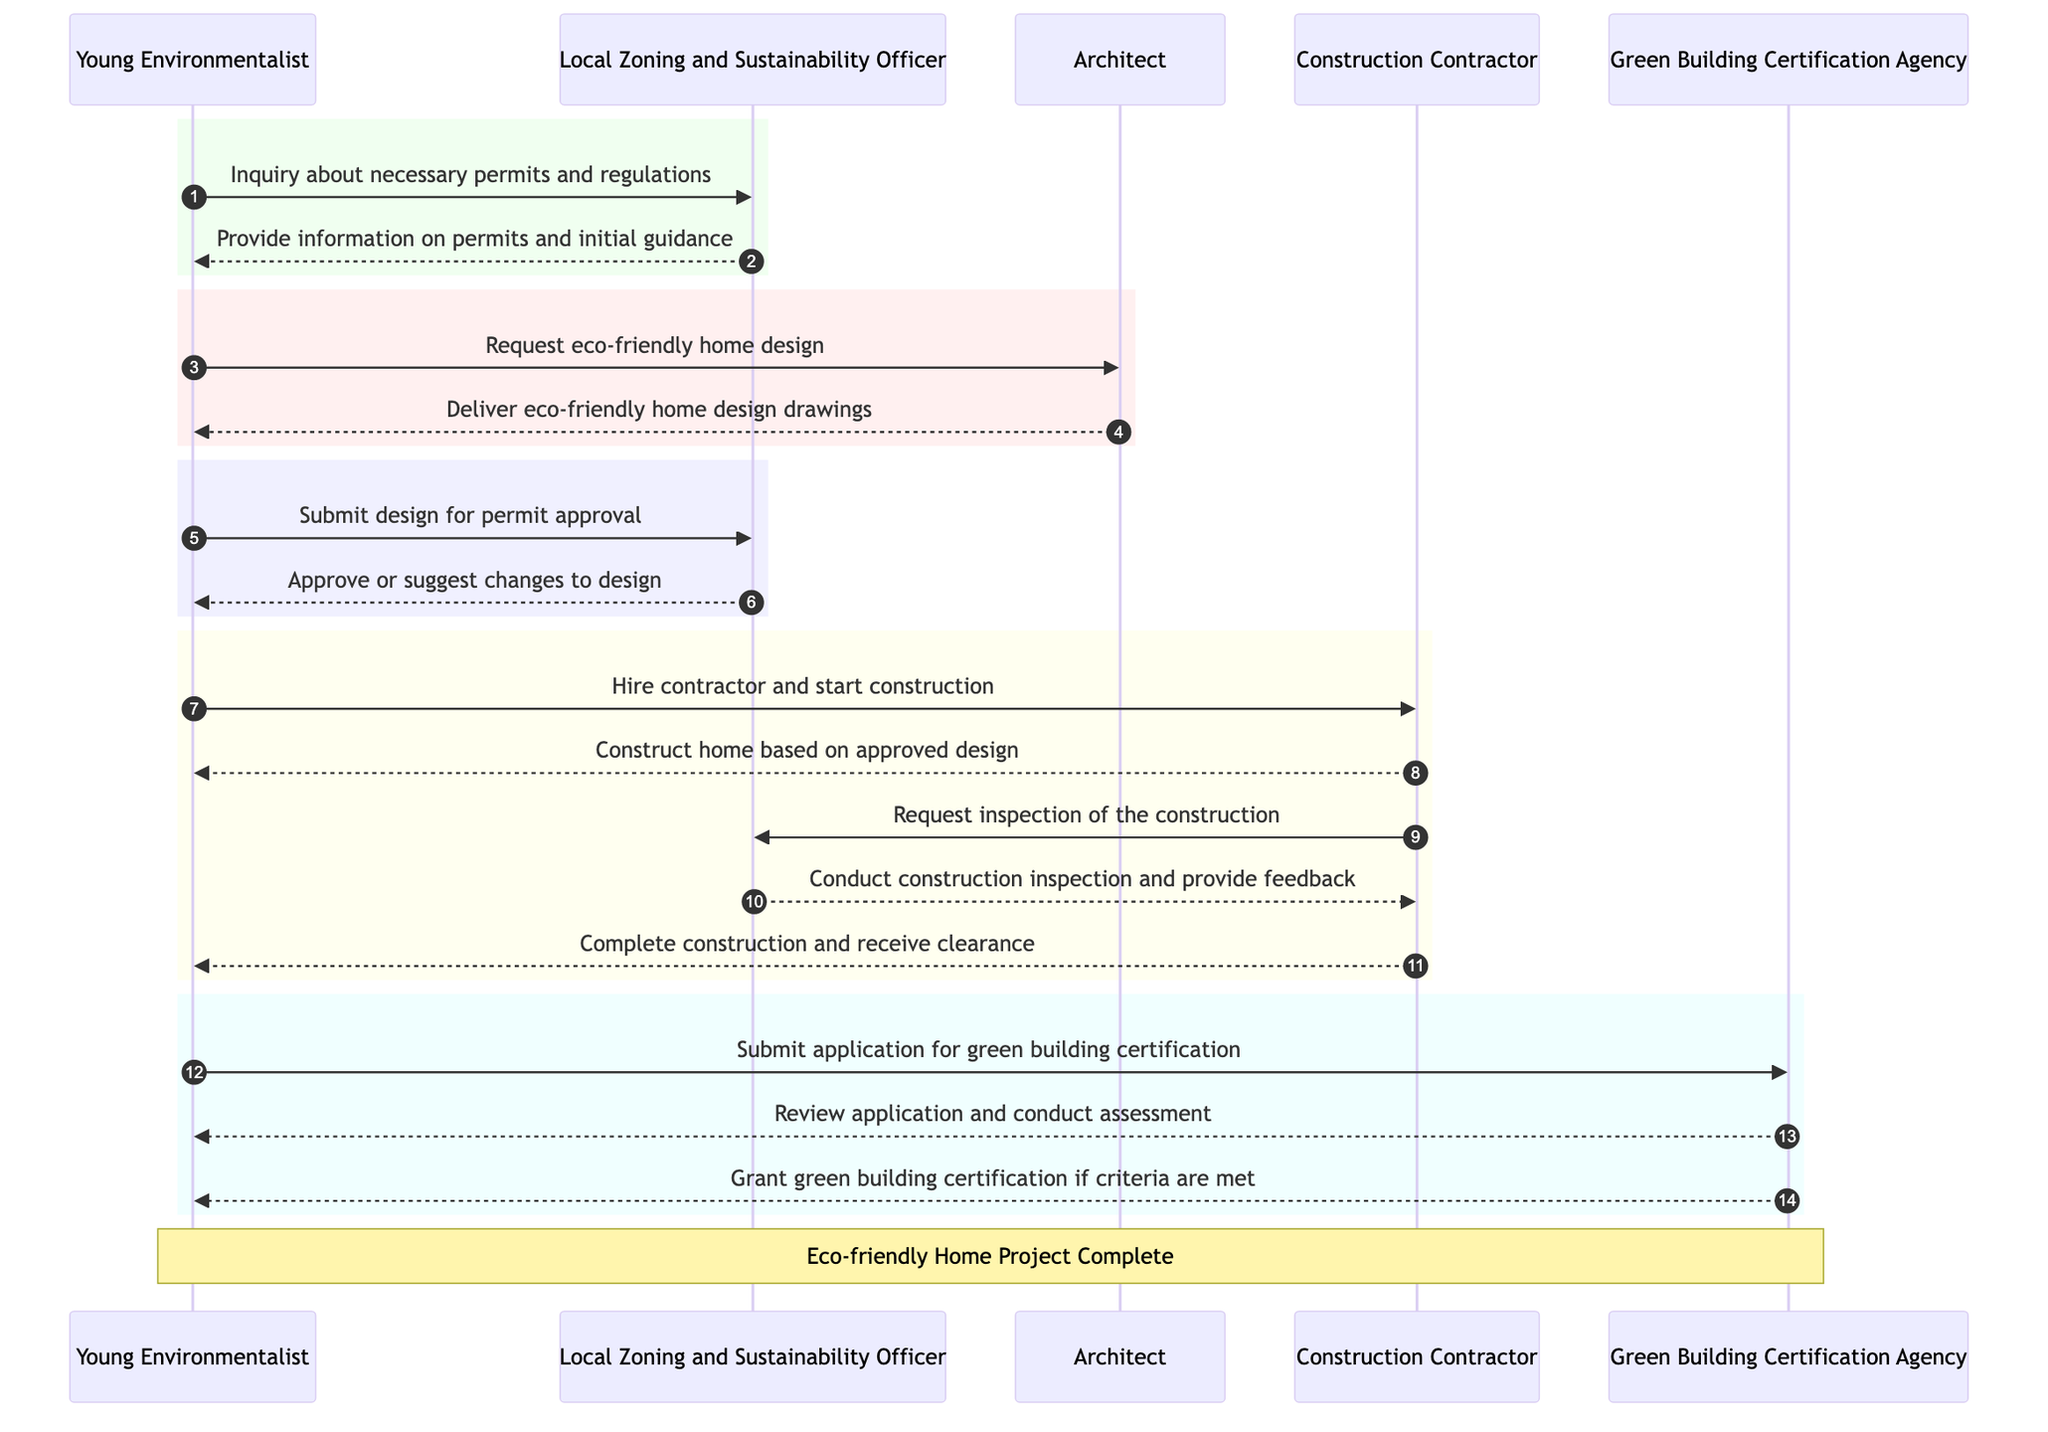What is the first action taken by the Young Environmentalist? The first action in the sequence diagram shows the Young Environmentalist making an inquiry about necessary permits and regulations to the Local Zoning and Sustainability Officer.
Answer: Inquiry about necessary permits and regulations How many participants are involved in this sequence? By counting the unique actors listed in the diagram, there are five participants: Young Environmentalist, Local Zoning and Sustainability Officer, Green Building Certification Agency, Architect, and Construction Contractor.
Answer: Five Who delivers the eco-friendly home design drawings? According to the diagram, after the Young Environmentalist requests an eco-friendly home design, the Architect is the one who delivers the design drawings.
Answer: Architect What is the role of the Local Zoning and Sustainability Officer in the construction phase? In the construction phase, the Local Zoning and Sustainability Officer requests an inspection from the Construction Contractor and conducts a construction inspection, providing feedback to ensure compliance.
Answer: Conduct construction inspection and provide feedback What happens after the application for green building certification is submitted? After the Young Environmentalist submits the application for green building certification, the Green Building Certification Agency reviews the application and conducts an assessment before granting certification if the criteria are met.
Answer: Review application and conduct assessment What step occurs immediately after the construction contractor completes the construction? Once the construction contractor completes the construction, the next step is to receive clearance from the Young Environmentalist, indicating that the project meets the established requirements.
Answer: Complete construction and receive clearance Which participant is involved in the permit approval step? The Local Zoning and Sustainability Officer is involved in the permit approval step, as they are the one who receives the design submission and makes decisions to approve or suggest changes.
Answer: Local Zoning and Sustainability Officer How many times does the Young Environmentalist interact with the Local Zoning and Sustainability Officer? The Young Environmentalist interacts with the Local Zoning and Sustainability Officer three times throughout the entire process: for inquiry, design submission, and receiving construction feedback.
Answer: Three What does the Green Building Certification Agency grant if criteria are met? If the application for green building certification meets the established criteria, the Green Building Certification Agency grants green building certification to the Young Environmentalist.
Answer: Grant green building certification if criteria are met 